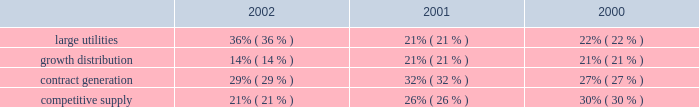Competitive supply aes 2019s competitive supply line of business consists of generating facilities that sell electricity directly to wholesale customers in competitive markets .
Additionally , as compared to the contract generation segment discussed above , these generating facilities generally sell less than 75% ( 75 % ) of their output pursuant to long-term contracts with pre-determined pricing provisions and/or sell into power pools , under shorter-term contracts or into daily spot markets .
The prices paid for electricity under short-term contracts and in the spot markets are unpredictable and can be , and from time to time have been , volatile .
The results of operations of aes 2019s competitive supply business are also more sensitive to the impact of market fluctuations in the price of electricity , natural gas , coal and other raw materials .
In the united kingdom , txu europe entered administration in november 2002 and is no longer performing under its contracts with drax and barry .
As described in the footnotes and in other sections of the discussion and analysis of financial condition and results of operations , txu europe 2019s failure to perform under its contracts has had a material adverse effect on the results of operations of these businesses .
Two aes competitive supply businesses , aes wolf hollow , l.p .
And granite ridge have fuel supply agreements with el paso merchant energy l.p .
An affiliate of el paso corp. , which has encountered financial difficulties .
The company does not believe the financial difficulties of el paso corp .
Will have a material adverse effect on el paso merchant energy l.p . 2019s performance under the supply agreement ; however , there can be no assurance that a further deterioration in el paso corp 2019s financial condition will not have a material adverse effect on the ability of el paso merchant energy l.p .
To perform its obligations .
While el paso corp 2019s financial condition may not have a material adverse effect on el paso merchant energy , l.p .
At this time , it could lead to a default under the aes wolf hollow , l.p . 2019s fuel supply agreement , in which case aes wolf hollow , l.p . 2019s lenders may seek to declare a default under its credit agreements .
Aes wolf hollow , l.p .
Is working in concert with its lenders to explore options to avoid such a default .
The revenues from our facilities that distribute electricity to end-use customers are generally subject to regulation .
These businesses are generally required to obtain third party approval or confirmation of rate increases before they can be passed on to the customers through tariffs .
These businesses comprise the large utilities and growth distribution segments of the company .
Revenues from contract generation and competitive supply are not regulated .
The distribution of revenues between the segments for the years ended december 31 , 2002 , 2001 and 2000 is as follows: .
Development costs certain subsidiaries and affiliates of the company ( domestic and non-u.s. ) are in various stages of developing and constructing greenfield power plants , some but not all of which have signed long-term contracts or made similar arrangements for the sale of electricity .
Successful completion depends upon overcoming substantial risks , including , but not limited to , risks relating to failures of siting , financing , construction , permitting , governmental approvals or the potential for termination of the power sales contract as a result of a failure to meet certain milestones .
As of december 31 , 2002 , capitalized costs for projects under development and in early stage construction were approximately $ 15 million and capitalized costs for projects under construction were approximately $ 3.2 billion .
The company believes .
For the years 2002 , 2001 , and 2000 , what was the average distribution of revenue to the large utilities segment? 
Computations: (((36% + 21%) + 22%) / 3)
Answer: 0.26333. 